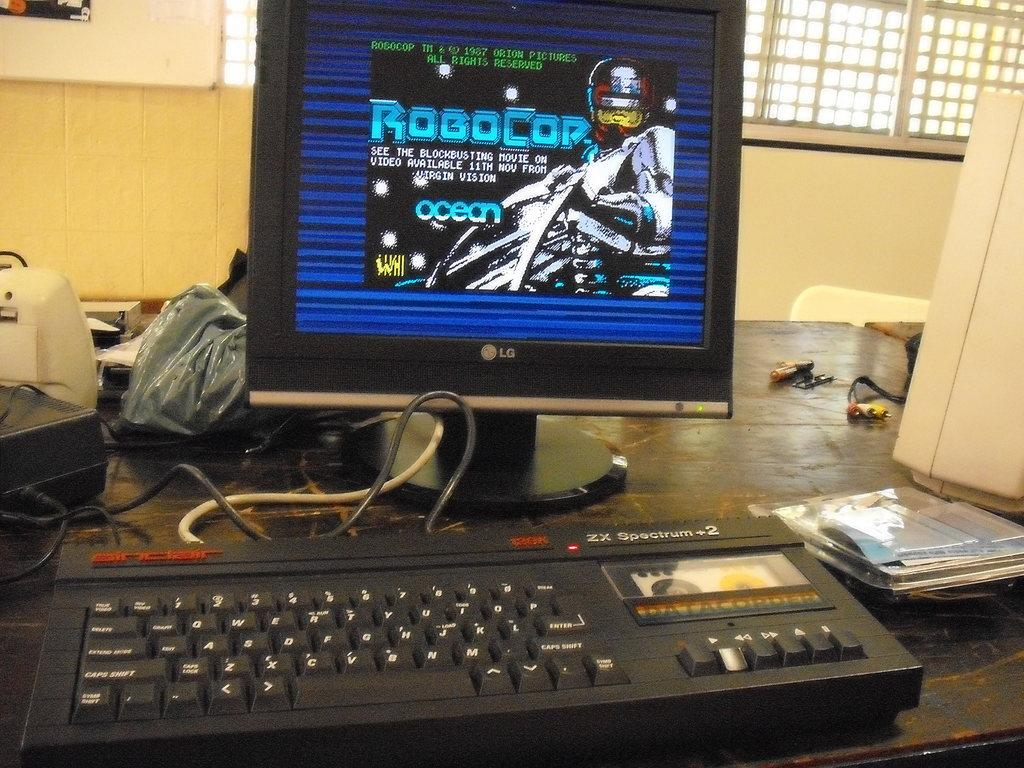<image>
Summarize the visual content of the image. An old PC with an LG monitor dispalying RoboCop. 